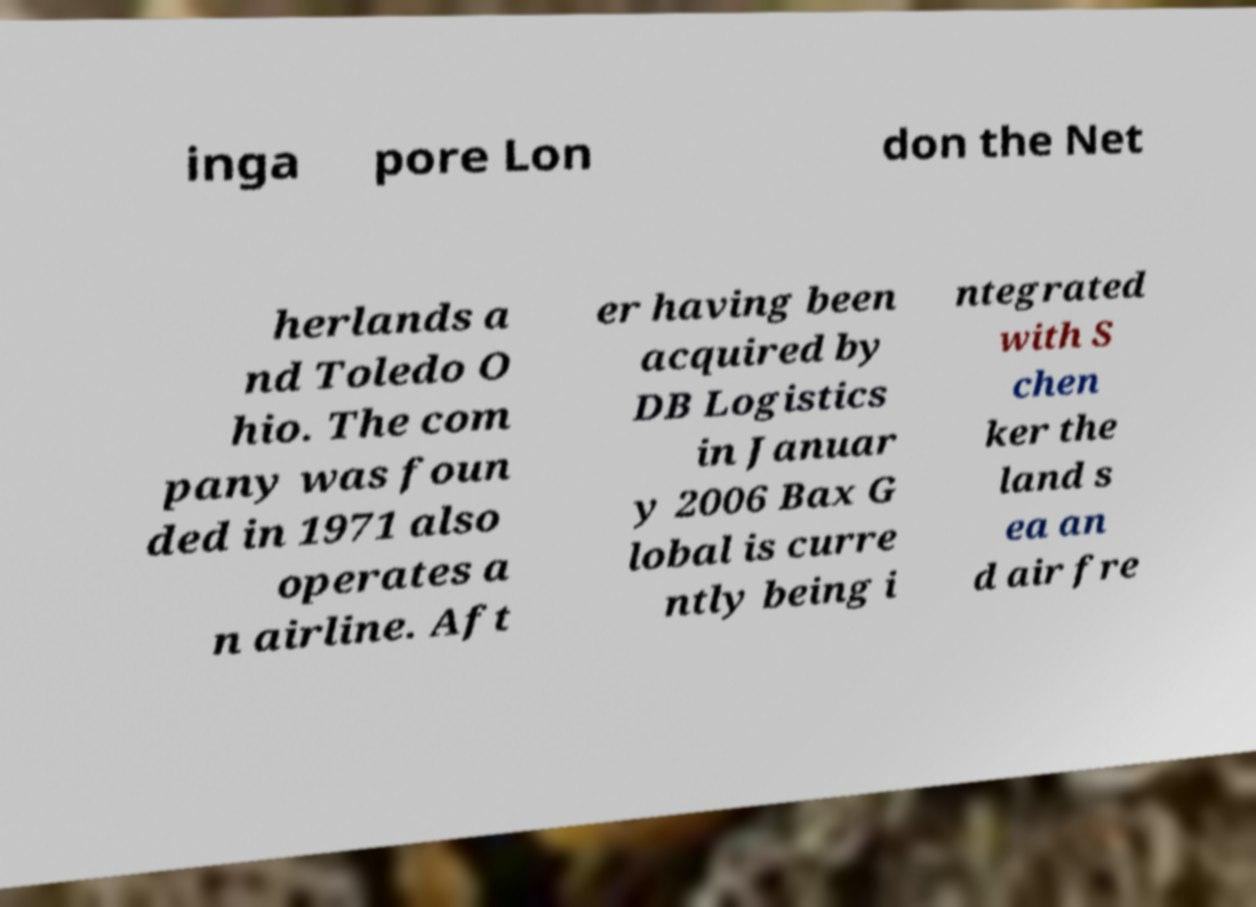Can you read and provide the text displayed in the image?This photo seems to have some interesting text. Can you extract and type it out for me? inga pore Lon don the Net herlands a nd Toledo O hio. The com pany was foun ded in 1971 also operates a n airline. Aft er having been acquired by DB Logistics in Januar y 2006 Bax G lobal is curre ntly being i ntegrated with S chen ker the land s ea an d air fre 